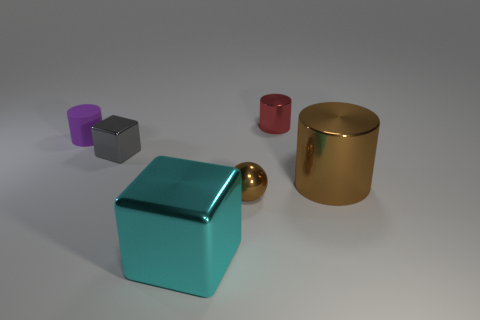Subtract all gray cubes. Subtract all gray cylinders. How many cubes are left? 1 Add 3 small brown cubes. How many objects exist? 9 Subtract all balls. How many objects are left? 5 Subtract 0 purple blocks. How many objects are left? 6 Subtract all tiny red cylinders. Subtract all large cylinders. How many objects are left? 4 Add 2 red things. How many red things are left? 3 Add 2 tiny cyan cylinders. How many tiny cyan cylinders exist? 2 